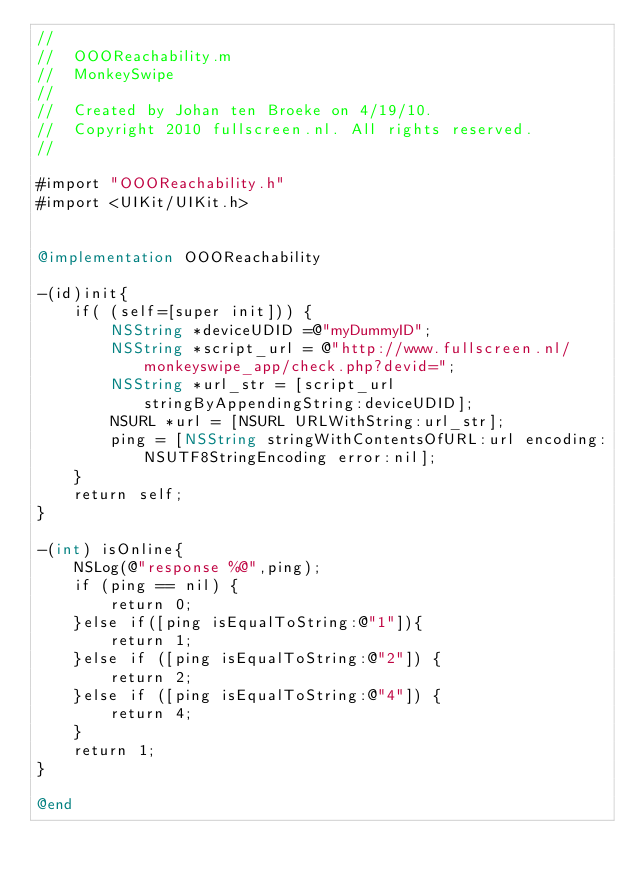<code> <loc_0><loc_0><loc_500><loc_500><_ObjectiveC_>//
//  OOOReachability.m
//  MonkeySwipe
//
//  Created by Johan ten Broeke on 4/19/10.
//  Copyright 2010 fullscreen.nl. All rights reserved.
//

#import "OOOReachability.h"
#import <UIKit/UIKit.h>


@implementation OOOReachability

-(id)init{
	if( (self=[super init])) {
        NSString *deviceUDID =@"myDummyID";
		NSString *script_url = @"http://www.fullscreen.nl/monkeyswipe_app/check.php?devid=";
		NSString *url_str = [script_url stringByAppendingString:deviceUDID];
		NSURL *url = [NSURL URLWithString:url_str];
		ping = [NSString stringWithContentsOfURL:url encoding:NSUTF8StringEncoding error:nil];
	}
	return self;
}

-(int) isOnline{
	NSLog(@"response %@",ping);
	if (ping == nil) {
		return 0;
	}else if([ping isEqualToString:@"1"]){
		return 1;
	}else if ([ping isEqualToString:@"2"]) {
		return 2;
	}else if ([ping isEqualToString:@"4"]) {
		return 4;
	}
	return 1;
}

@end
</code> 